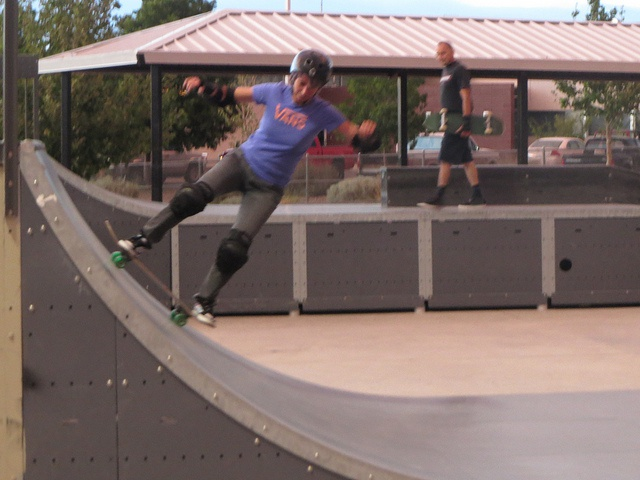Describe the objects in this image and their specific colors. I can see people in darkgray, black, gray, blue, and maroon tones, people in darkgray, black, brown, gray, and maroon tones, car in darkgray, gray, and black tones, car in darkgray, gray, and black tones, and skateboard in darkgray, gray, and black tones in this image. 